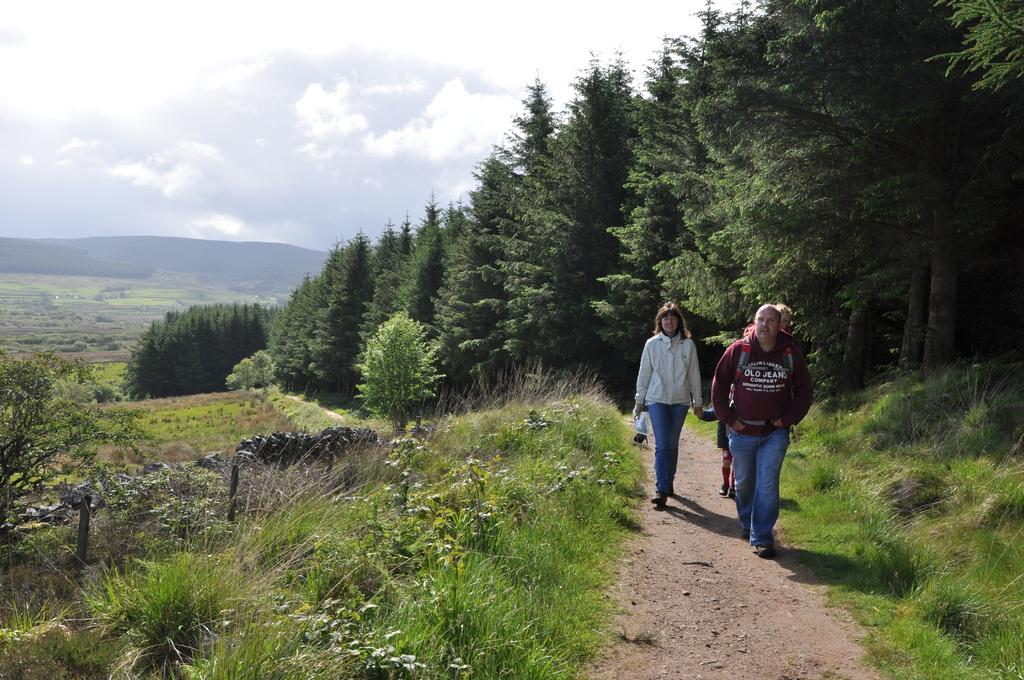What type of vegetation can be seen in the image? There are trees in the image. What geographical feature is present in the image? There is a hill in the image. What type of ground cover is visible in the image? There is grass in the image. What are the people in the image doing? The people are walking in the image. What is the condition of the sky in the image? The sky is cloudy in the image. What is the opinion of the trees about the weather in the image? Trees do not have opinions, as they are inanimate objects. Can you see any hands holding a glass in the image? There is no mention of hands or glasses in the image; it features trees, a hill, grass, people walking, and a cloudy sky. 